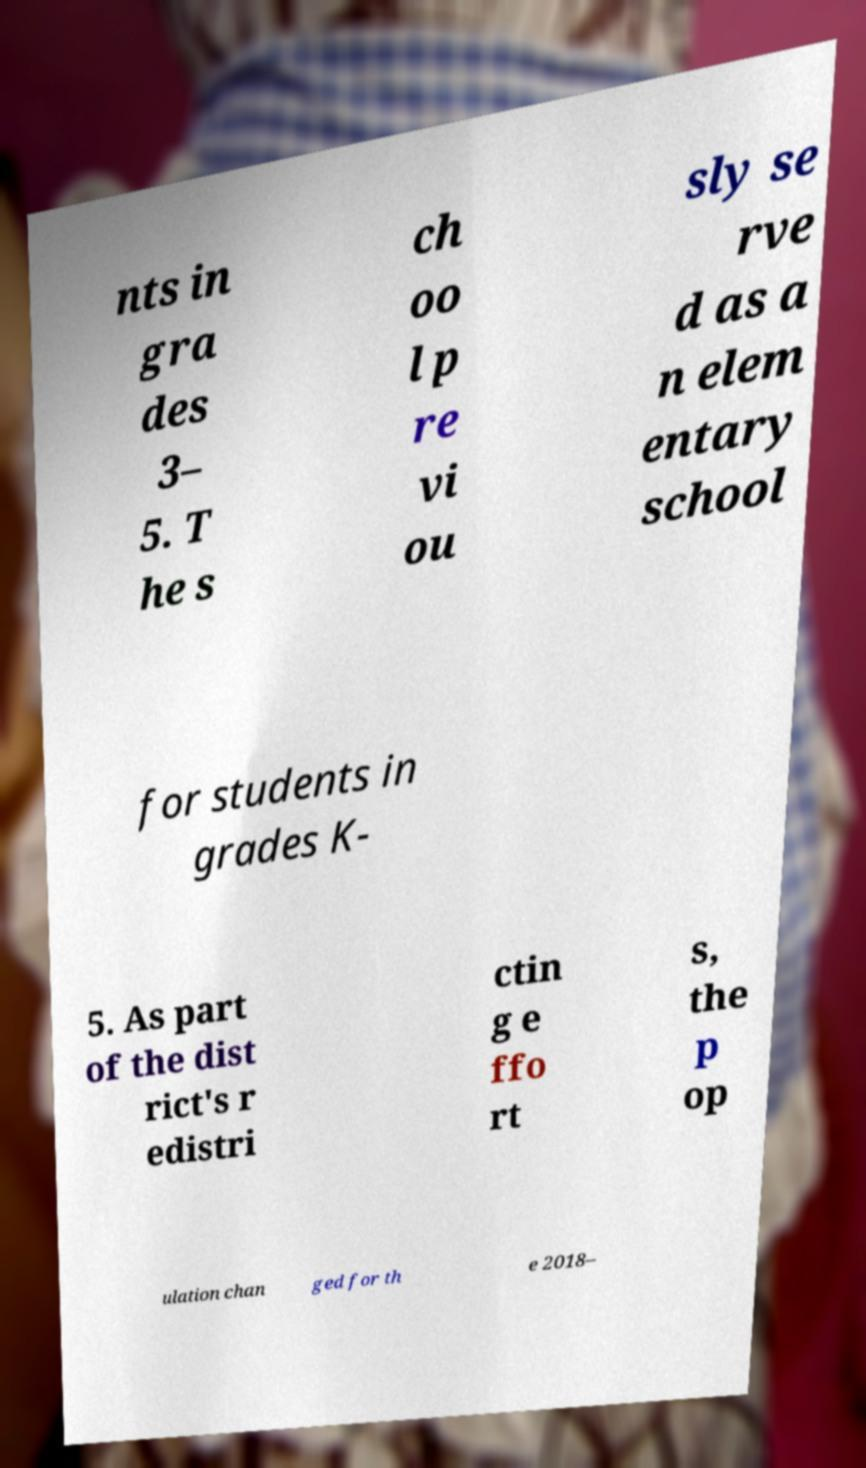Can you accurately transcribe the text from the provided image for me? nts in gra des 3– 5. T he s ch oo l p re vi ou sly se rve d as a n elem entary school for students in grades K- 5. As part of the dist rict's r edistri ctin g e ffo rt s, the p op ulation chan ged for th e 2018– 